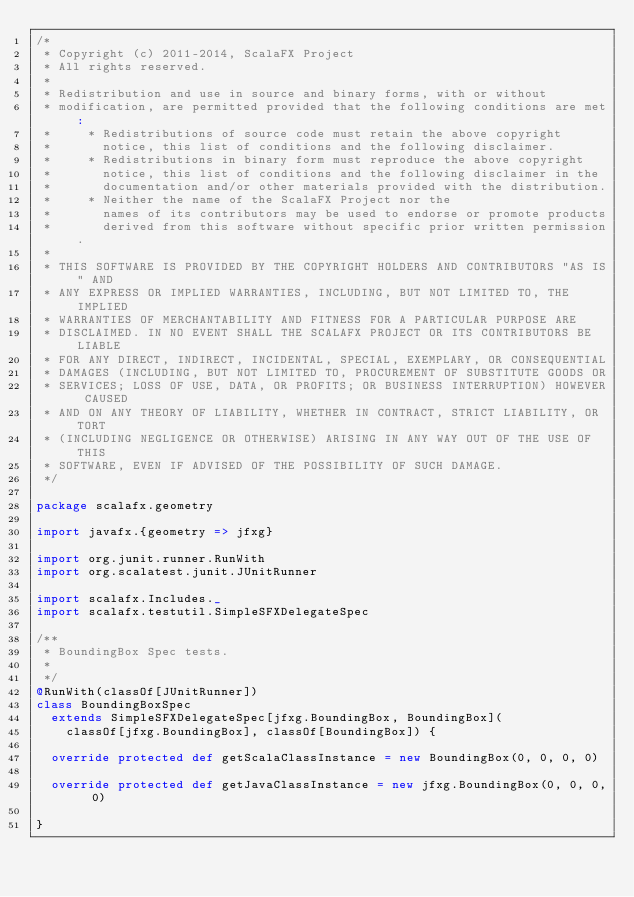<code> <loc_0><loc_0><loc_500><loc_500><_Scala_>/*
 * Copyright (c) 2011-2014, ScalaFX Project
 * All rights reserved.
 *
 * Redistribution and use in source and binary forms, with or without
 * modification, are permitted provided that the following conditions are met:
 *     * Redistributions of source code must retain the above copyright
 *       notice, this list of conditions and the following disclaimer.
 *     * Redistributions in binary form must reproduce the above copyright
 *       notice, this list of conditions and the following disclaimer in the
 *       documentation and/or other materials provided with the distribution.
 *     * Neither the name of the ScalaFX Project nor the
 *       names of its contributors may be used to endorse or promote products
 *       derived from this software without specific prior written permission.
 *
 * THIS SOFTWARE IS PROVIDED BY THE COPYRIGHT HOLDERS AND CONTRIBUTORS "AS IS" AND
 * ANY EXPRESS OR IMPLIED WARRANTIES, INCLUDING, BUT NOT LIMITED TO, THE IMPLIED
 * WARRANTIES OF MERCHANTABILITY AND FITNESS FOR A PARTICULAR PURPOSE ARE
 * DISCLAIMED. IN NO EVENT SHALL THE SCALAFX PROJECT OR ITS CONTRIBUTORS BE LIABLE
 * FOR ANY DIRECT, INDIRECT, INCIDENTAL, SPECIAL, EXEMPLARY, OR CONSEQUENTIAL
 * DAMAGES (INCLUDING, BUT NOT LIMITED TO, PROCUREMENT OF SUBSTITUTE GOODS OR
 * SERVICES; LOSS OF USE, DATA, OR PROFITS; OR BUSINESS INTERRUPTION) HOWEVER CAUSED
 * AND ON ANY THEORY OF LIABILITY, WHETHER IN CONTRACT, STRICT LIABILITY, OR TORT
 * (INCLUDING NEGLIGENCE OR OTHERWISE) ARISING IN ANY WAY OUT OF THE USE OF THIS
 * SOFTWARE, EVEN IF ADVISED OF THE POSSIBILITY OF SUCH DAMAGE.
 */

package scalafx.geometry

import javafx.{geometry => jfxg}

import org.junit.runner.RunWith
import org.scalatest.junit.JUnitRunner

import scalafx.Includes._
import scalafx.testutil.SimpleSFXDelegateSpec

/**
 * BoundingBox Spec tests.
 *
 */
@RunWith(classOf[JUnitRunner])
class BoundingBoxSpec
  extends SimpleSFXDelegateSpec[jfxg.BoundingBox, BoundingBox](
    classOf[jfxg.BoundingBox], classOf[BoundingBox]) {

  override protected def getScalaClassInstance = new BoundingBox(0, 0, 0, 0)

  override protected def getJavaClassInstance = new jfxg.BoundingBox(0, 0, 0, 0)

}</code> 